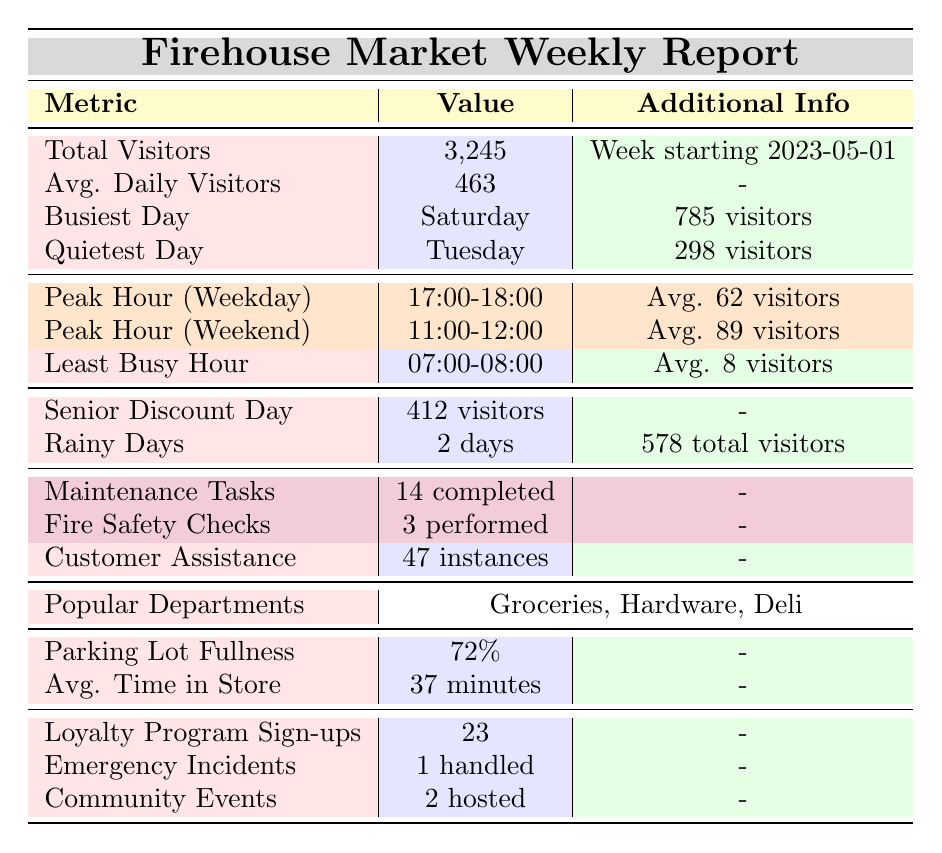What is the total number of visitors for the week starting May 1, 2023? The table indicates that the total visitors for that week are listed directly as 3,245.
Answer: 3,245 Which day had the highest number of visitors? The table states that Saturday was the busiest day, with 785 visitors.
Answer: Saturday How many visitors did the quietest day have? According to the table, the quietest day is Tuesday, which had 298 visitors.
Answer: 298 What is the average daily number of visitors? The table specifies that the average daily visitors is 463.
Answer: 463 What hour is the peak hour on weekdays? The table lists the peak hour for weekdays as 17:00-18:00.
Answer: 17:00-18:00 How many maintenance tasks were completed? The table shows that 14 maintenance tasks were completed during that week.
Answer: 14 What percentage of the parking lot was full? The table indicates that the parking lot fullness percentage is 72%.
Answer: 72% On average, how much time did visitors spend in the store? The average time spent in the store is stated in the table as 37 minutes.
Answer: 37 minutes How many visitors were there on senior discount day? The table notes that there were 412 visitors on senior discount day.
Answer: 412 What is the total number of visitors on rainy days? The table mentions that there were 578 total visitors on the 2 rainy days during that week.
Answer: 578 What is the average number of visitors during the peak hour on weekends? The peak hour on weekends has an average of 89 visitors according to the table.
Answer: 89 Was the average daily visitor count higher than the number of visitors on Tuesday? The average daily visitor count is 463, while Tuesday had 298 visitors. Since 463 > 298, the statement is true.
Answer: Yes If we consider only the busiest day, Saturday, how many more visitors were there on that day compared to the quietest day, Tuesday? Saturday had 785 visitors and Tuesday had 298 visitors. The difference is 785 - 298 = 487 visitors.
Answer: 487 Did more loyalty program sign-ups occur than emergency incidents handled? The table shows 23 loyalty program sign-ups and 1 emergency incident. Since 23 > 1, the statement is true.
Answer: Yes What is the average number of customers assisted per day during that week? The total customer assistance instances are 47 over 7 days (the week), resulting in an average of 47 / 7 ≈ 6.71.
Answer: Approximately 7 If the average daily visitors were to increase by 100, what would be the new average? Adding 100 to the average daily visitors of 463 gives 563 (463 + 100 = 563).
Answer: 563 